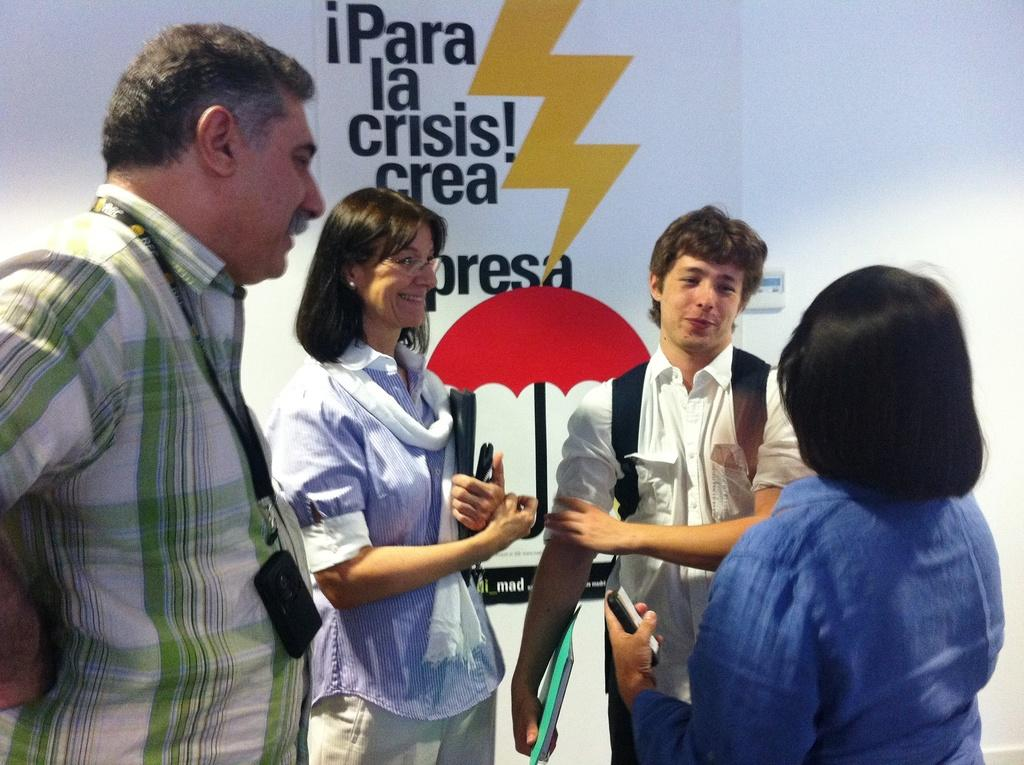How many people are in the image? There are four persons in the image. What can be seen on the wall in the background? There is a poster on the wall in the background. What is depicted on the poster? The poster contains a picture of an umbrella. Are there any words on the poster? Yes, text is written on the poster. What type of quill is being used to write on the poster? There is no quill present in the image; the text on the poster is likely written using a modern writing instrument. 